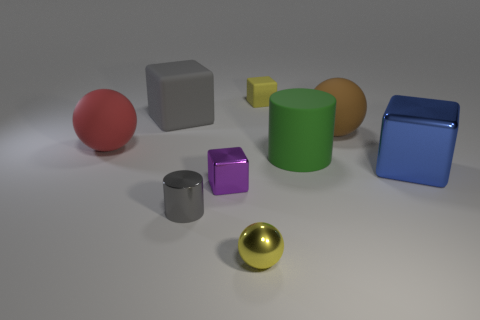What is the purple object made of?
Your answer should be very brief. Metal. Is there any other thing of the same color as the matte cylinder?
Offer a terse response. No. Do the large gray block and the large brown sphere have the same material?
Your response must be concise. Yes. How many red matte balls are behind the small purple object that is behind the tiny yellow thing in front of the tiny rubber thing?
Make the answer very short. 1. How many big purple metallic objects are there?
Give a very brief answer. 0. Are there fewer purple shiny blocks to the right of the small yellow block than purple metallic blocks that are in front of the tiny gray thing?
Give a very brief answer. No. Are there fewer blue metallic cubes that are in front of the metallic ball than cyan objects?
Make the answer very short. No. What material is the large sphere on the left side of the small block behind the matte sphere that is left of the big green rubber thing?
Ensure brevity in your answer.  Rubber. How many objects are either small cubes behind the large rubber block or shiny blocks on the right side of the yellow shiny object?
Offer a terse response. 2. There is another big thing that is the same shape as the large gray rubber thing; what is it made of?
Your answer should be very brief. Metal. 